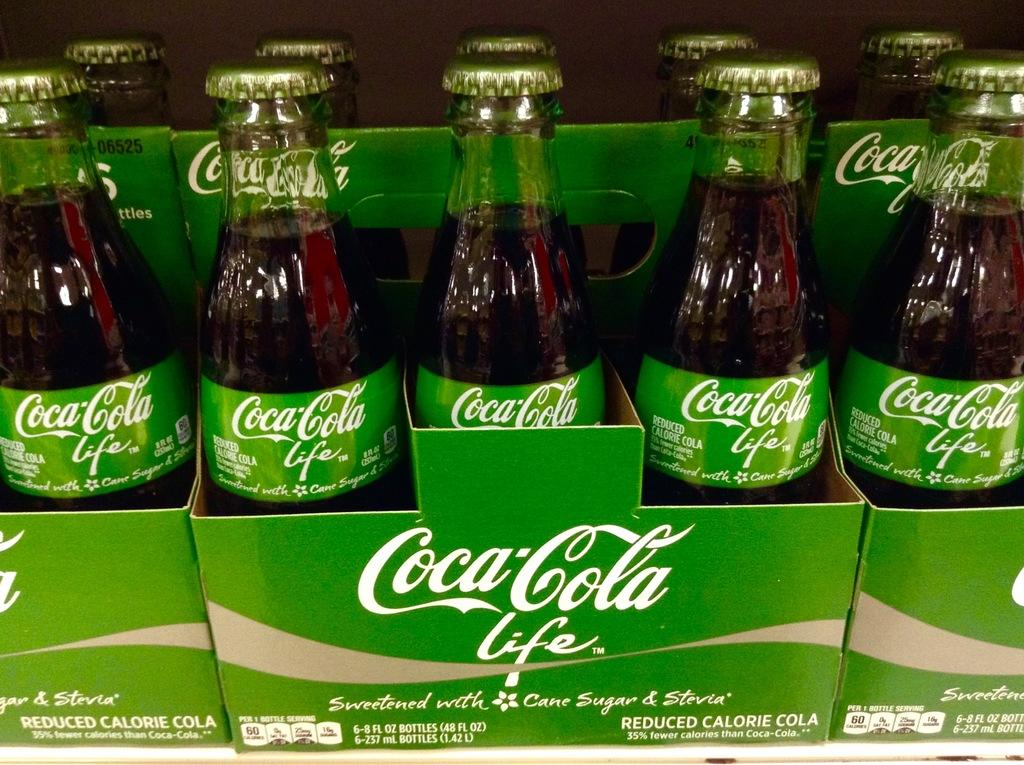<image>
Create a compact narrative representing the image presented. Packs of Coca-Cola life sit lined up next to each other. 